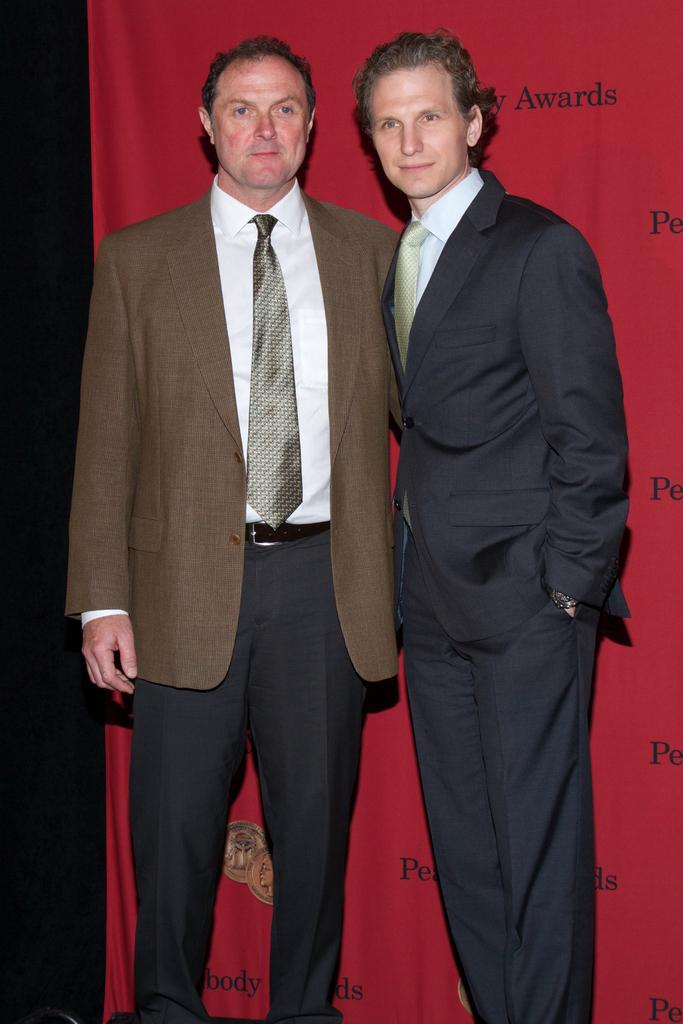How many people are in the image? There are two people standing in the center of the image. What are the people wearing? The people are wearing suits. What can be seen in the background of the image? There is a curtain in the background of the image. What type of bun is being used to hold the curtain in the image? There is no bun present in the image; it features two people wearing suits and a curtain in the background. How does the milk affect the impulse of the people in the image? There is no milk or mention of impulse in the image; it only shows two people wearing suits and a curtain in the background. 